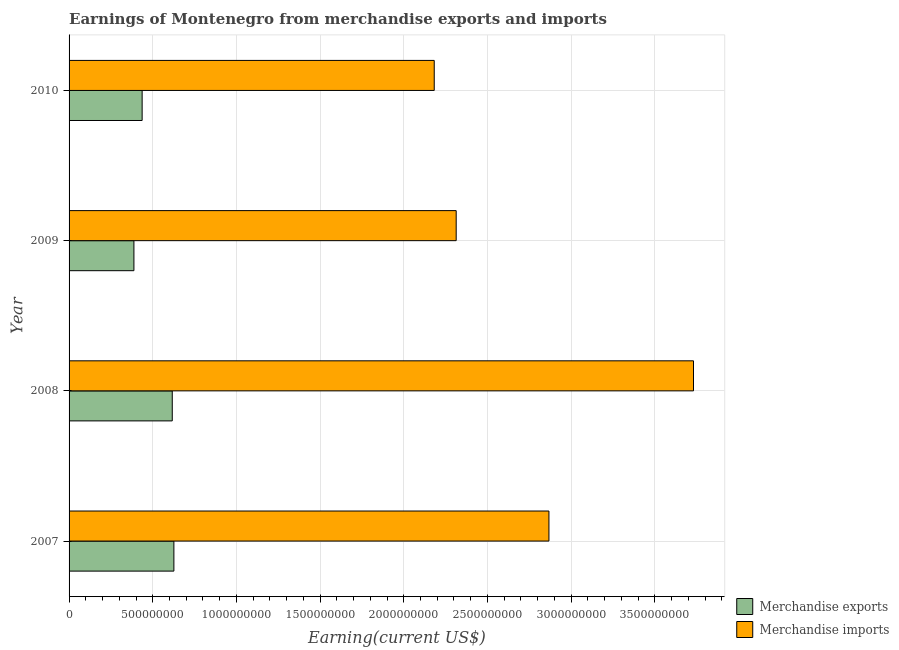How many groups of bars are there?
Your answer should be compact. 4. Are the number of bars per tick equal to the number of legend labels?
Give a very brief answer. Yes. How many bars are there on the 2nd tick from the bottom?
Your response must be concise. 2. What is the label of the 2nd group of bars from the top?
Your response must be concise. 2009. What is the earnings from merchandise exports in 2008?
Ensure brevity in your answer.  6.17e+08. Across all years, what is the maximum earnings from merchandise exports?
Your answer should be very brief. 6.26e+08. Across all years, what is the minimum earnings from merchandise imports?
Keep it short and to the point. 2.18e+09. In which year was the earnings from merchandise exports maximum?
Your response must be concise. 2007. What is the total earnings from merchandise imports in the graph?
Provide a succinct answer. 1.11e+1. What is the difference between the earnings from merchandise exports in 2008 and that in 2009?
Keep it short and to the point. 2.29e+08. What is the difference between the earnings from merchandise imports in 2008 and the earnings from merchandise exports in 2010?
Ensure brevity in your answer.  3.29e+09. What is the average earnings from merchandise imports per year?
Offer a very short reply. 2.77e+09. In the year 2007, what is the difference between the earnings from merchandise imports and earnings from merchandise exports?
Make the answer very short. 2.24e+09. What is the ratio of the earnings from merchandise exports in 2008 to that in 2009?
Provide a short and direct response. 1.59. What is the difference between the highest and the second highest earnings from merchandise imports?
Your answer should be compact. 8.64e+08. What is the difference between the highest and the lowest earnings from merchandise exports?
Offer a very short reply. 2.39e+08. In how many years, is the earnings from merchandise exports greater than the average earnings from merchandise exports taken over all years?
Provide a short and direct response. 2. What is the difference between two consecutive major ticks on the X-axis?
Make the answer very short. 5.00e+08. Where does the legend appear in the graph?
Make the answer very short. Bottom right. How many legend labels are there?
Give a very brief answer. 2. How are the legend labels stacked?
Offer a terse response. Vertical. What is the title of the graph?
Make the answer very short. Earnings of Montenegro from merchandise exports and imports. What is the label or title of the X-axis?
Your response must be concise. Earning(current US$). What is the label or title of the Y-axis?
Keep it short and to the point. Year. What is the Earning(current US$) in Merchandise exports in 2007?
Your response must be concise. 6.26e+08. What is the Earning(current US$) in Merchandise imports in 2007?
Offer a very short reply. 2.87e+09. What is the Earning(current US$) in Merchandise exports in 2008?
Your answer should be compact. 6.17e+08. What is the Earning(current US$) of Merchandise imports in 2008?
Give a very brief answer. 3.73e+09. What is the Earning(current US$) in Merchandise exports in 2009?
Ensure brevity in your answer.  3.88e+08. What is the Earning(current US$) in Merchandise imports in 2009?
Make the answer very short. 2.31e+09. What is the Earning(current US$) of Merchandise exports in 2010?
Offer a terse response. 4.37e+08. What is the Earning(current US$) in Merchandise imports in 2010?
Ensure brevity in your answer.  2.18e+09. Across all years, what is the maximum Earning(current US$) in Merchandise exports?
Provide a short and direct response. 6.26e+08. Across all years, what is the maximum Earning(current US$) in Merchandise imports?
Provide a short and direct response. 3.73e+09. Across all years, what is the minimum Earning(current US$) of Merchandise exports?
Provide a short and direct response. 3.88e+08. Across all years, what is the minimum Earning(current US$) in Merchandise imports?
Your answer should be very brief. 2.18e+09. What is the total Earning(current US$) of Merchandise exports in the graph?
Your answer should be compact. 2.07e+09. What is the total Earning(current US$) of Merchandise imports in the graph?
Give a very brief answer. 1.11e+1. What is the difference between the Earning(current US$) in Merchandise exports in 2007 and that in 2008?
Offer a very short reply. 9.67e+06. What is the difference between the Earning(current US$) in Merchandise imports in 2007 and that in 2008?
Your answer should be very brief. -8.64e+08. What is the difference between the Earning(current US$) of Merchandise exports in 2007 and that in 2009?
Provide a succinct answer. 2.39e+08. What is the difference between the Earning(current US$) of Merchandise imports in 2007 and that in 2009?
Give a very brief answer. 5.54e+08. What is the difference between the Earning(current US$) of Merchandise exports in 2007 and that in 2010?
Provide a succinct answer. 1.90e+08. What is the difference between the Earning(current US$) in Merchandise imports in 2007 and that in 2010?
Keep it short and to the point. 6.85e+08. What is the difference between the Earning(current US$) of Merchandise exports in 2008 and that in 2009?
Offer a very short reply. 2.29e+08. What is the difference between the Earning(current US$) in Merchandise imports in 2008 and that in 2009?
Offer a terse response. 1.42e+09. What is the difference between the Earning(current US$) in Merchandise exports in 2008 and that in 2010?
Provide a succinct answer. 1.80e+08. What is the difference between the Earning(current US$) in Merchandise imports in 2008 and that in 2010?
Your answer should be very brief. 1.55e+09. What is the difference between the Earning(current US$) of Merchandise exports in 2009 and that in 2010?
Offer a very short reply. -4.90e+07. What is the difference between the Earning(current US$) in Merchandise imports in 2009 and that in 2010?
Give a very brief answer. 1.31e+08. What is the difference between the Earning(current US$) in Merchandise exports in 2007 and the Earning(current US$) in Merchandise imports in 2008?
Ensure brevity in your answer.  -3.10e+09. What is the difference between the Earning(current US$) of Merchandise exports in 2007 and the Earning(current US$) of Merchandise imports in 2009?
Offer a very short reply. -1.69e+09. What is the difference between the Earning(current US$) of Merchandise exports in 2007 and the Earning(current US$) of Merchandise imports in 2010?
Your answer should be compact. -1.56e+09. What is the difference between the Earning(current US$) in Merchandise exports in 2008 and the Earning(current US$) in Merchandise imports in 2009?
Provide a short and direct response. -1.70e+09. What is the difference between the Earning(current US$) in Merchandise exports in 2008 and the Earning(current US$) in Merchandise imports in 2010?
Ensure brevity in your answer.  -1.57e+09. What is the difference between the Earning(current US$) in Merchandise exports in 2009 and the Earning(current US$) in Merchandise imports in 2010?
Your answer should be very brief. -1.79e+09. What is the average Earning(current US$) of Merchandise exports per year?
Your response must be concise. 5.17e+08. What is the average Earning(current US$) in Merchandise imports per year?
Ensure brevity in your answer.  2.77e+09. In the year 2007, what is the difference between the Earning(current US$) of Merchandise exports and Earning(current US$) of Merchandise imports?
Make the answer very short. -2.24e+09. In the year 2008, what is the difference between the Earning(current US$) in Merchandise exports and Earning(current US$) in Merchandise imports?
Ensure brevity in your answer.  -3.11e+09. In the year 2009, what is the difference between the Earning(current US$) in Merchandise exports and Earning(current US$) in Merchandise imports?
Give a very brief answer. -1.93e+09. In the year 2010, what is the difference between the Earning(current US$) of Merchandise exports and Earning(current US$) of Merchandise imports?
Provide a succinct answer. -1.75e+09. What is the ratio of the Earning(current US$) of Merchandise exports in 2007 to that in 2008?
Keep it short and to the point. 1.02. What is the ratio of the Earning(current US$) of Merchandise imports in 2007 to that in 2008?
Ensure brevity in your answer.  0.77. What is the ratio of the Earning(current US$) in Merchandise exports in 2007 to that in 2009?
Offer a terse response. 1.62. What is the ratio of the Earning(current US$) of Merchandise imports in 2007 to that in 2009?
Provide a succinct answer. 1.24. What is the ratio of the Earning(current US$) of Merchandise exports in 2007 to that in 2010?
Provide a short and direct response. 1.43. What is the ratio of the Earning(current US$) in Merchandise imports in 2007 to that in 2010?
Give a very brief answer. 1.31. What is the ratio of the Earning(current US$) of Merchandise exports in 2008 to that in 2009?
Offer a very short reply. 1.59. What is the ratio of the Earning(current US$) of Merchandise imports in 2008 to that in 2009?
Your answer should be compact. 1.61. What is the ratio of the Earning(current US$) of Merchandise exports in 2008 to that in 2010?
Make the answer very short. 1.41. What is the ratio of the Earning(current US$) in Merchandise imports in 2008 to that in 2010?
Your answer should be very brief. 1.71. What is the ratio of the Earning(current US$) of Merchandise exports in 2009 to that in 2010?
Provide a short and direct response. 0.89. What is the ratio of the Earning(current US$) of Merchandise imports in 2009 to that in 2010?
Provide a succinct answer. 1.06. What is the difference between the highest and the second highest Earning(current US$) in Merchandise exports?
Give a very brief answer. 9.67e+06. What is the difference between the highest and the second highest Earning(current US$) in Merchandise imports?
Ensure brevity in your answer.  8.64e+08. What is the difference between the highest and the lowest Earning(current US$) of Merchandise exports?
Your answer should be compact. 2.39e+08. What is the difference between the highest and the lowest Earning(current US$) of Merchandise imports?
Provide a short and direct response. 1.55e+09. 